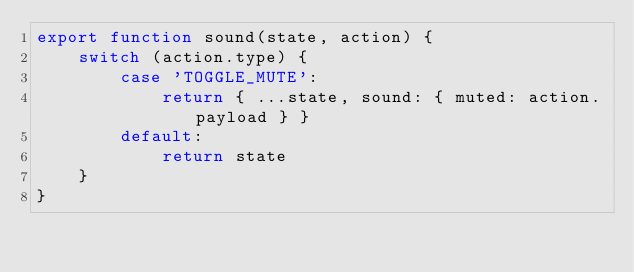<code> <loc_0><loc_0><loc_500><loc_500><_JavaScript_>export function sound(state, action) {
    switch (action.type) {
        case 'TOGGLE_MUTE':
            return { ...state, sound: { muted: action.payload } }
        default:
            return state
    }
}
</code> 